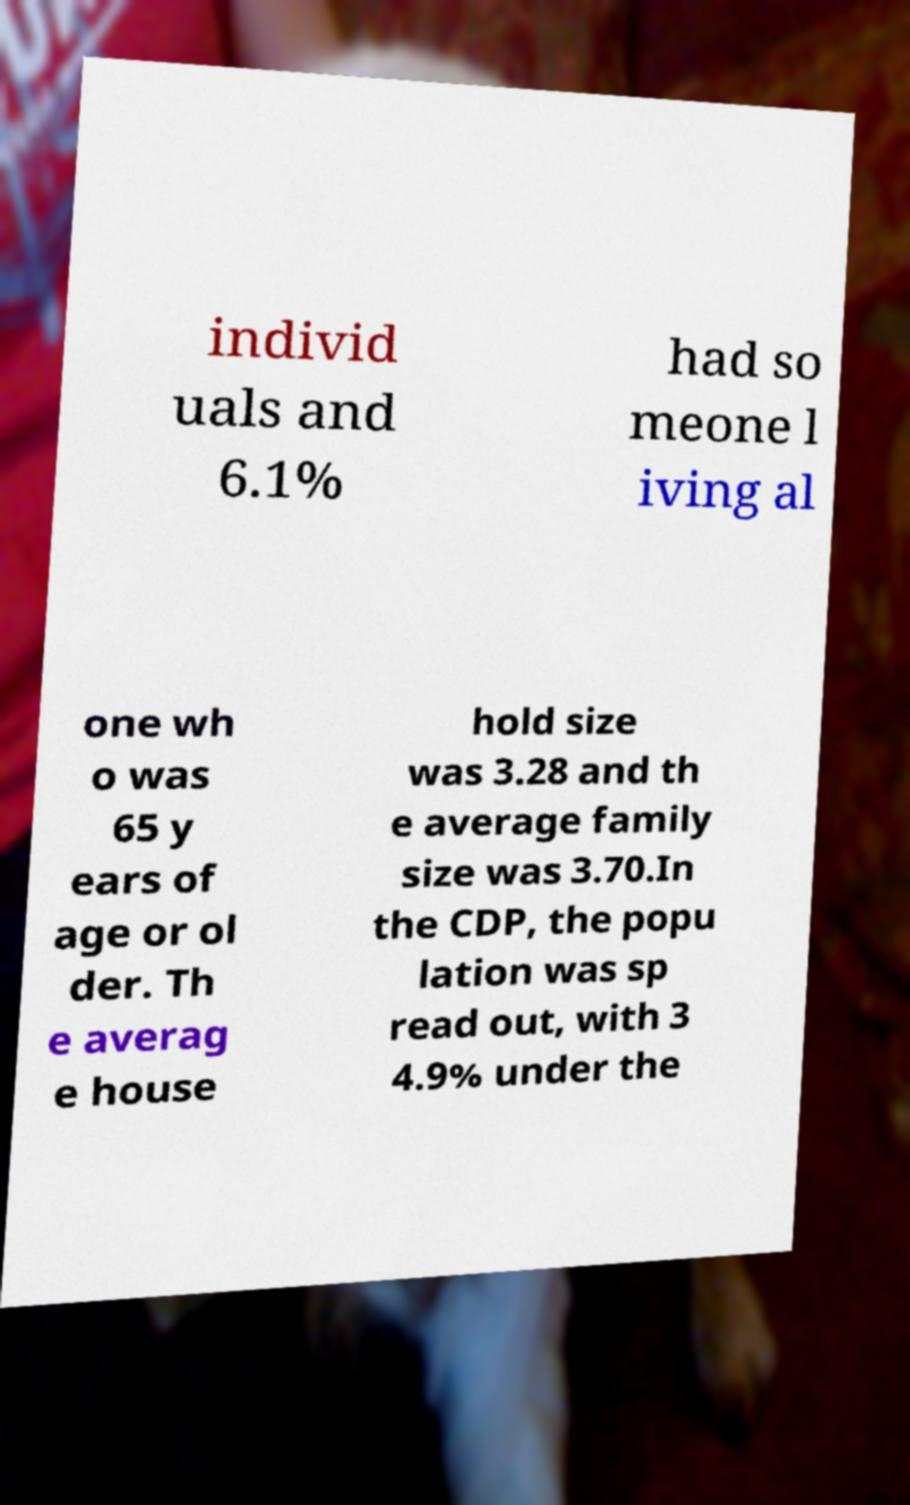Can you read and provide the text displayed in the image?This photo seems to have some interesting text. Can you extract and type it out for me? individ uals and 6.1% had so meone l iving al one wh o was 65 y ears of age or ol der. Th e averag e house hold size was 3.28 and th e average family size was 3.70.In the CDP, the popu lation was sp read out, with 3 4.9% under the 